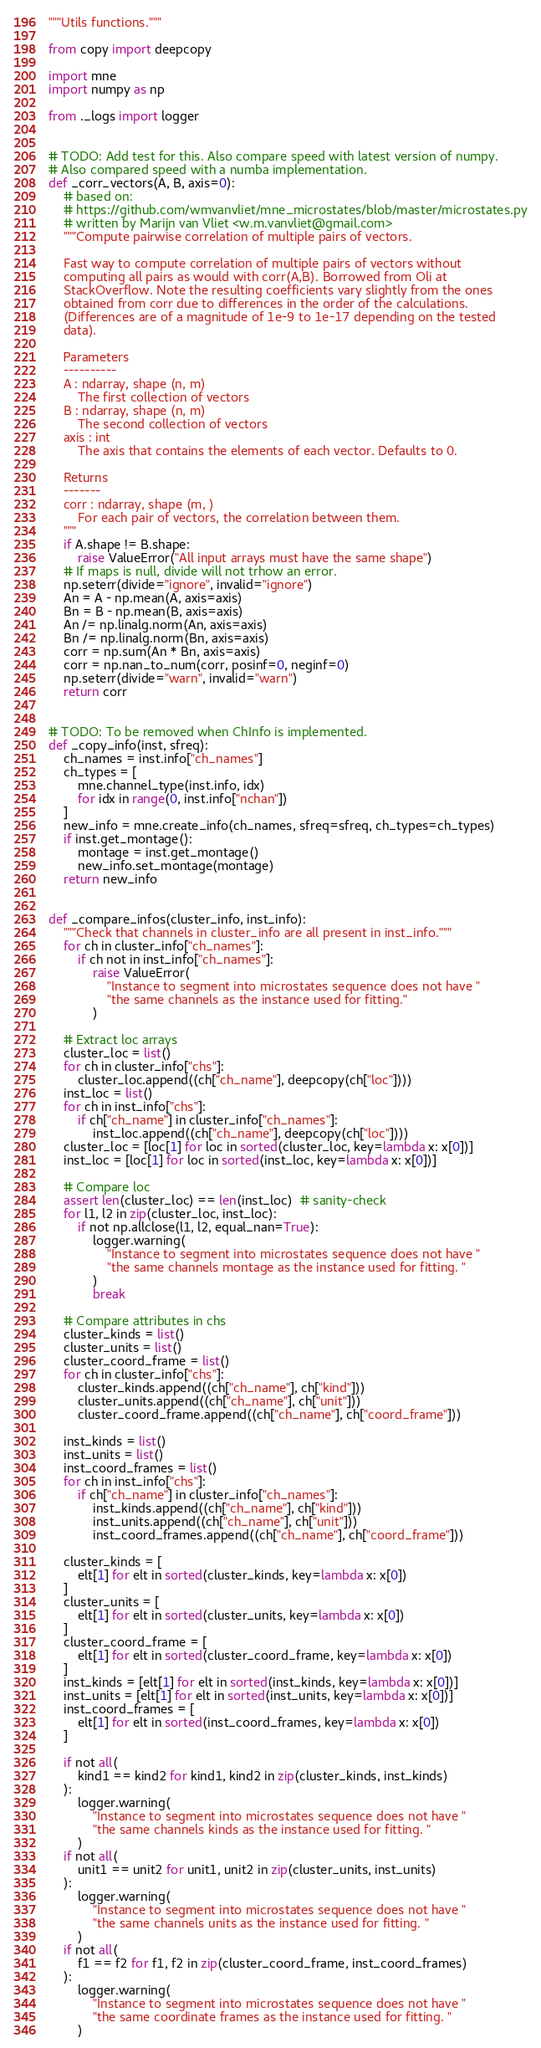<code> <loc_0><loc_0><loc_500><loc_500><_Python_>"""Utils functions."""

from copy import deepcopy

import mne
import numpy as np

from ._logs import logger


# TODO: Add test for this. Also compare speed with latest version of numpy.
# Also compared speed with a numba implementation.
def _corr_vectors(A, B, axis=0):
    # based on:
    # https://github.com/wmvanvliet/mne_microstates/blob/master/microstates.py
    # written by Marijn van Vliet <w.m.vanvliet@gmail.com>
    """Compute pairwise correlation of multiple pairs of vectors.

    Fast way to compute correlation of multiple pairs of vectors without
    computing all pairs as would with corr(A,B). Borrowed from Oli at
    StackOverflow. Note the resulting coefficients vary slightly from the ones
    obtained from corr due to differences in the order of the calculations.
    (Differences are of a magnitude of 1e-9 to 1e-17 depending on the tested
    data).

    Parameters
    ----------
    A : ndarray, shape (n, m)
        The first collection of vectors
    B : ndarray, shape (n, m)
        The second collection of vectors
    axis : int
        The axis that contains the elements of each vector. Defaults to 0.

    Returns
    -------
    corr : ndarray, shape (m, )
        For each pair of vectors, the correlation between them.
    """
    if A.shape != B.shape:
        raise ValueError("All input arrays must have the same shape")
    # If maps is null, divide will not trhow an error.
    np.seterr(divide="ignore", invalid="ignore")
    An = A - np.mean(A, axis=axis)
    Bn = B - np.mean(B, axis=axis)
    An /= np.linalg.norm(An, axis=axis)
    Bn /= np.linalg.norm(Bn, axis=axis)
    corr = np.sum(An * Bn, axis=axis)
    corr = np.nan_to_num(corr, posinf=0, neginf=0)
    np.seterr(divide="warn", invalid="warn")
    return corr


# TODO: To be removed when ChInfo is implemented.
def _copy_info(inst, sfreq):
    ch_names = inst.info["ch_names"]
    ch_types = [
        mne.channel_type(inst.info, idx)
        for idx in range(0, inst.info["nchan"])
    ]
    new_info = mne.create_info(ch_names, sfreq=sfreq, ch_types=ch_types)
    if inst.get_montage():
        montage = inst.get_montage()
        new_info.set_montage(montage)
    return new_info


def _compare_infos(cluster_info, inst_info):
    """Check that channels in cluster_info are all present in inst_info."""
    for ch in cluster_info["ch_names"]:
        if ch not in inst_info["ch_names"]:
            raise ValueError(
                "Instance to segment into microstates sequence does not have "
                "the same channels as the instance used for fitting."
            )

    # Extract loc arrays
    cluster_loc = list()
    for ch in cluster_info["chs"]:
        cluster_loc.append((ch["ch_name"], deepcopy(ch["loc"])))
    inst_loc = list()
    for ch in inst_info["chs"]:
        if ch["ch_name"] in cluster_info["ch_names"]:
            inst_loc.append((ch["ch_name"], deepcopy(ch["loc"])))
    cluster_loc = [loc[1] for loc in sorted(cluster_loc, key=lambda x: x[0])]
    inst_loc = [loc[1] for loc in sorted(inst_loc, key=lambda x: x[0])]

    # Compare loc
    assert len(cluster_loc) == len(inst_loc)  # sanity-check
    for l1, l2 in zip(cluster_loc, inst_loc):
        if not np.allclose(l1, l2, equal_nan=True):
            logger.warning(
                "Instance to segment into microstates sequence does not have "
                "the same channels montage as the instance used for fitting. "
            )
            break

    # Compare attributes in chs
    cluster_kinds = list()
    cluster_units = list()
    cluster_coord_frame = list()
    for ch in cluster_info["chs"]:
        cluster_kinds.append((ch["ch_name"], ch["kind"]))
        cluster_units.append((ch["ch_name"], ch["unit"]))
        cluster_coord_frame.append((ch["ch_name"], ch["coord_frame"]))

    inst_kinds = list()
    inst_units = list()
    inst_coord_frames = list()
    for ch in inst_info["chs"]:
        if ch["ch_name"] in cluster_info["ch_names"]:
            inst_kinds.append((ch["ch_name"], ch["kind"]))
            inst_units.append((ch["ch_name"], ch["unit"]))
            inst_coord_frames.append((ch["ch_name"], ch["coord_frame"]))

    cluster_kinds = [
        elt[1] for elt in sorted(cluster_kinds, key=lambda x: x[0])
    ]
    cluster_units = [
        elt[1] for elt in sorted(cluster_units, key=lambda x: x[0])
    ]
    cluster_coord_frame = [
        elt[1] for elt in sorted(cluster_coord_frame, key=lambda x: x[0])
    ]
    inst_kinds = [elt[1] for elt in sorted(inst_kinds, key=lambda x: x[0])]
    inst_units = [elt[1] for elt in sorted(inst_units, key=lambda x: x[0])]
    inst_coord_frames = [
        elt[1] for elt in sorted(inst_coord_frames, key=lambda x: x[0])
    ]

    if not all(
        kind1 == kind2 for kind1, kind2 in zip(cluster_kinds, inst_kinds)
    ):
        logger.warning(
            "Instance to segment into microstates sequence does not have "
            "the same channels kinds as the instance used for fitting. "
        )
    if not all(
        unit1 == unit2 for unit1, unit2 in zip(cluster_units, inst_units)
    ):
        logger.warning(
            "Instance to segment into microstates sequence does not have "
            "the same channels units as the instance used for fitting. "
        )
    if not all(
        f1 == f2 for f1, f2 in zip(cluster_coord_frame, inst_coord_frames)
    ):
        logger.warning(
            "Instance to segment into microstates sequence does not have "
            "the same coordinate frames as the instance used for fitting. "
        )
</code> 